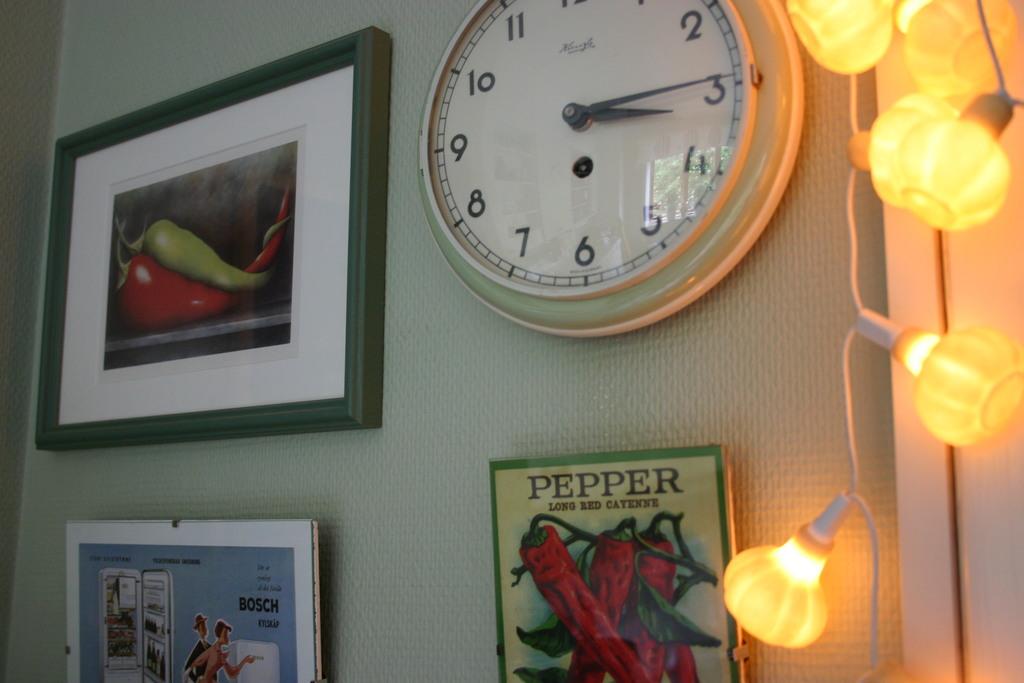About what time is it?
Your response must be concise. 3:15. 